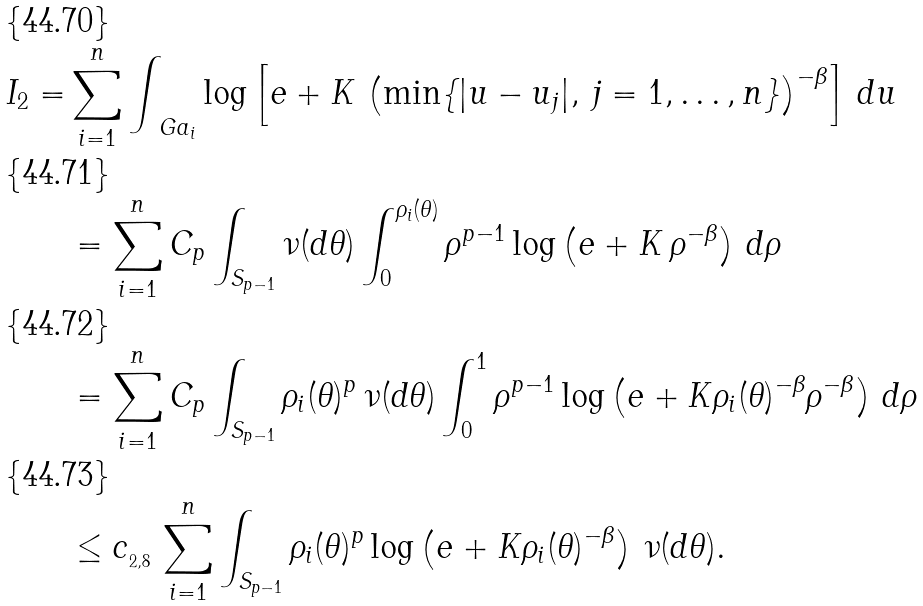Convert formula to latex. <formula><loc_0><loc_0><loc_500><loc_500>I _ { 2 } = & \sum _ { i = 1 } ^ { n } \int _ { \ G a _ { i } } \log \left [ e + K \, \left ( \min \{ | u - u _ { j } | , \, j = 1 , \dots , n \} \right ) ^ { - \beta } \right ] \, d u \\ & = \sum _ { i = 1 } ^ { n } C _ { p } \int _ { S _ { p - 1 } } \nu ( d \theta ) \int _ { 0 } ^ { \rho _ { i } ( \theta ) } \rho ^ { p - 1 } \log \left ( e + K \, \rho ^ { - \beta } \right ) \, d \rho \\ & = \sum _ { i = 1 } ^ { n } C _ { p } \int _ { S _ { p - 1 } } \rho _ { i } ( \theta ) ^ { p } \, \nu ( d \theta ) \int _ { 0 } ^ { 1 } \rho ^ { p - 1 } \log \left ( e + K \rho _ { i } ( \theta ) ^ { - \beta } \rho ^ { - \beta } \right ) \, d \rho \\ & \leq c _ { _ { 2 , 8 } } \, \sum _ { i = 1 } ^ { n } \int _ { S _ { p - 1 } } \rho _ { i } ( \theta ) ^ { p } \log \left ( e + K \rho _ { i } ( \theta ) ^ { - \beta } \right ) \, \nu ( d \theta ) .</formula> 